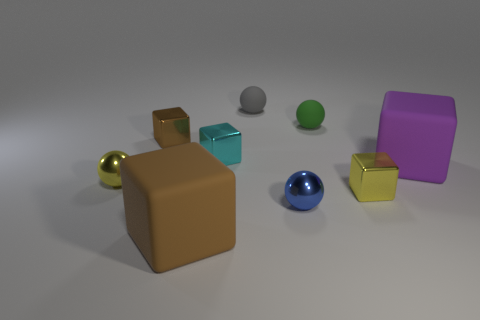The sphere that is made of the same material as the small green object is what size?
Give a very brief answer. Small. What is the gray ball made of?
Give a very brief answer. Rubber. How many rubber blocks have the same size as the cyan metal object?
Offer a very short reply. 0. Are there any large purple things of the same shape as the small brown metal thing?
Your response must be concise. Yes. There is a object that is the same size as the brown rubber block; what color is it?
Offer a terse response. Purple. What is the color of the matte block behind the large cube to the left of the blue object?
Make the answer very short. Purple. What shape is the tiny yellow object to the right of the tiny yellow object that is on the left side of the big cube on the left side of the purple rubber thing?
Provide a succinct answer. Cube. What number of rubber blocks are behind the large thing that is on the left side of the tiny cyan metal object?
Keep it short and to the point. 1. Are the tiny brown object and the small gray ball made of the same material?
Provide a short and direct response. No. What number of blue balls are on the left side of the tiny yellow shiny thing that is left of the big block that is to the left of the small gray ball?
Keep it short and to the point. 0. 